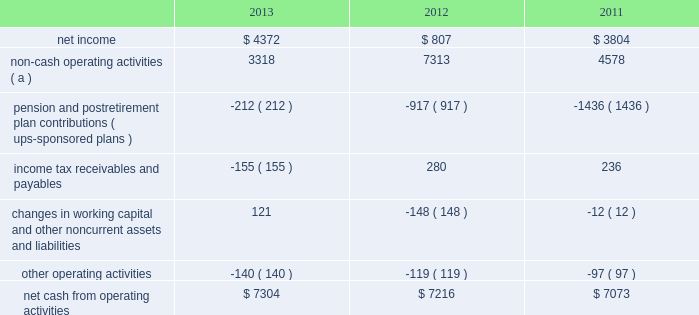United parcel service , inc .
And subsidiaries management's discussion and analysis of financial condition and results of operations liquidity and capital resources operating activities the following is a summary of the significant sources ( uses ) of cash from operating activities ( amounts in millions ) : .
( a ) represents depreciation and amortization , gains and losses on derivative and foreign exchange transactions , deferred income taxes , provisions for uncollectible accounts , pension and postretirement benefit expense , stock compensation expense , impairment charges and other non-cash items .
Cash from operating activities remained strong throughout the 2011 to 2013 time period .
Operating cash flow was favorably impacted in 2013 , compared with 2012 , by lower contributions into our defined benefit pension and postretirement benefit plans ; however , this was partially offset by certain tnt express transaction-related charges , as well as changes in income tax receivables and payables .
We paid a termination fee to tnt express of 20ac200 million ( $ 268 million ) under the agreement to terminate the merger protocol in the first quarter of 2013 .
Additionally , the cash payments for income taxes increased in 2013 compared with 2012 , and were impacted by the timing of current tax deductions .
Except for discretionary or accelerated fundings of our plans , contributions to our company-sponsored pension plans have largely varied based on whether any minimum funding requirements are present for individual pension plans .
2022 in 2013 , we did not have any required , nor make any discretionary , contributions to our primary company-sponsored pension plans in the u.s .
2022 in 2012 , we made a $ 355 million required contribution to the ups ibt pension plan .
2022 in 2011 , we made a $ 1.2 billion contribution to the ups ibt pension plan , which satisfied our 2011 contribution requirements and also approximately $ 440 million in contributions that would not have been required until after 2011 .
2022 the remaining contributions in the 2011 through 2013 period were largely due to contributions to our international pension plans and u.s .
Postretirement medical benefit plans .
As discussed further in the 201ccontractual commitments 201d section , we have minimum funding requirements in the next several years , primarily related to the ups ibt pension , ups retirement and ups pension plans .
As of december 31 , 2013 , the total of our worldwide holdings of cash and cash equivalents was $ 4.665 billion .
Approximately 45%-55% ( 45%-55 % ) of cash and cash equivalents was held by foreign subsidiaries throughout the year .
The amount of cash held by our u.s .
And foreign subsidiaries fluctuates throughout the year due to a variety of factors , including the timing of cash receipts and disbursements in the normal course of business .
Cash provided by operating activities in the united states continues to be our primary source of funds to finance domestic operating needs , capital expenditures , share repurchases and dividend payments to shareowners .
To the extent that such amounts represent previously untaxed earnings , the cash held by foreign subsidiaries would be subject to tax if such amounts were repatriated in the form of dividends ; however , not all international cash balances would have to be repatriated in the form of a dividend if returned to the u.s .
When amounts earned by foreign subsidiaries are expected to be indefinitely reinvested , no accrual for taxes is provided. .
What percentage of net cash from operating activities was derived from non-cash operating activities in 2012? 
Computations: (7313 / 7216)
Answer: 1.01344. 